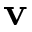<formula> <loc_0><loc_0><loc_500><loc_500>v</formula> 